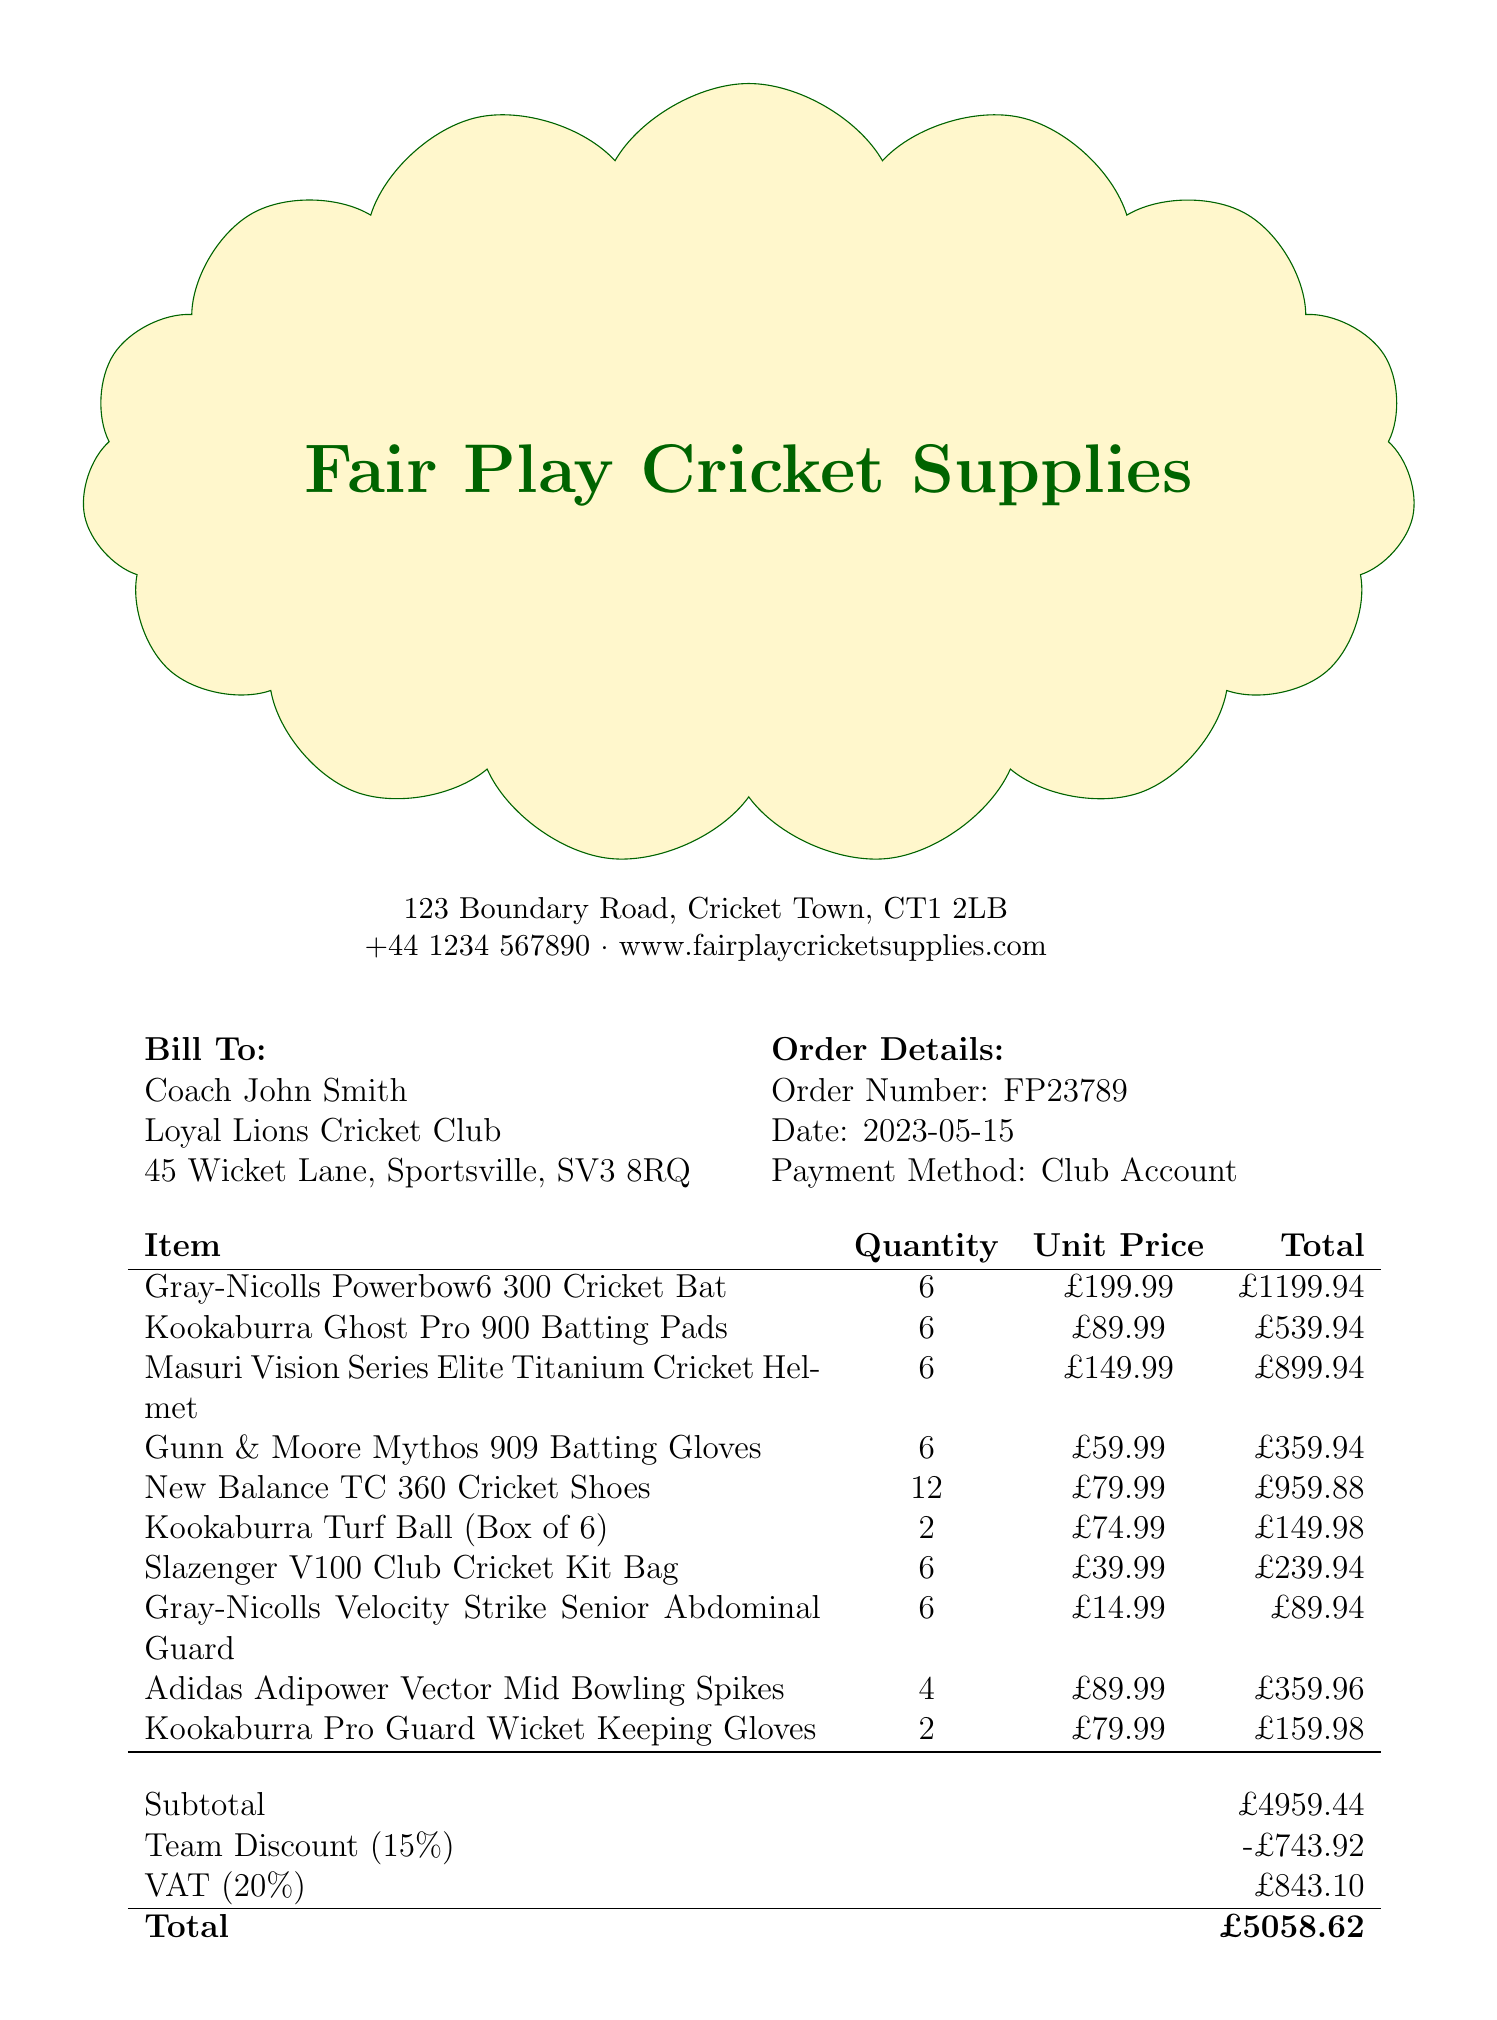what is the name of the store? The store name is listed prominently at the top of the document.
Answer: Fair Play Cricket Supplies who is the customer? The customer name is provided in the customer information section.
Answer: Coach John Smith what is the total amount due? The total amount is indicated in the pricing section of the receipt.
Answer: £5058.62 what is the date of the order? The order date is mentioned in the order details section.
Answer: 2023-05-15 how many items did the team purchase? The total quantity of all items purchased can be calculated from the itemized list.
Answer: 46 what percentage is the team discount? The team discount percentage is specifically stated in the pricing section.
Answer: 15% what is the subtotal before the discount? The subtotal is listed right before the team discount in the pricing section.
Answer: £4959.44 when is the estimated delivery date? The estimated delivery date is mentioned in the additional information section.
Answer: 2023-05-22 what loyalty points were earned on this purchase? The loyalty points earned are listed in the additional information section.
Answer: 506 